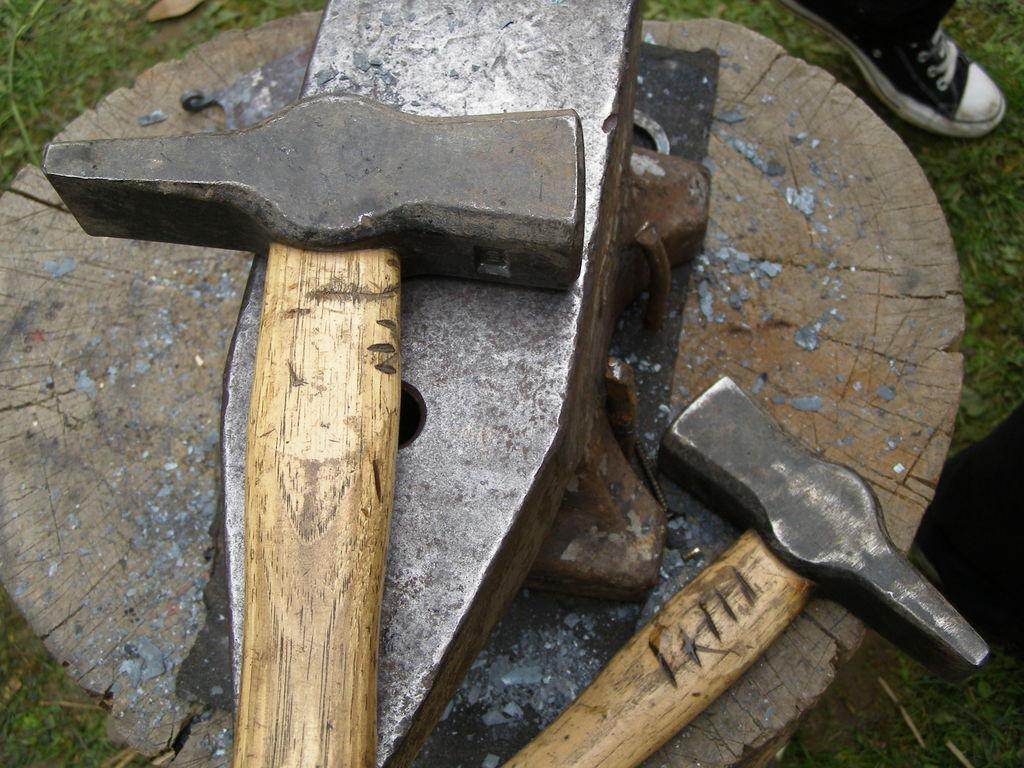What tools are located in the center of the image? There are hammers and chisels in the center of the image. What object is being worked on in the image? There is a wood trunk in the center of the image. What type of vegetation can be seen at the top and bottom of the image? There is grass at the top and bottom of the image. Can you describe the person's presence in the image? A person's leg is visible at the top of the image. How many tomatoes are being held by the person in the image? There are no tomatoes present in the image. What is the person's partner doing in the image? There is no partner present in the image. 